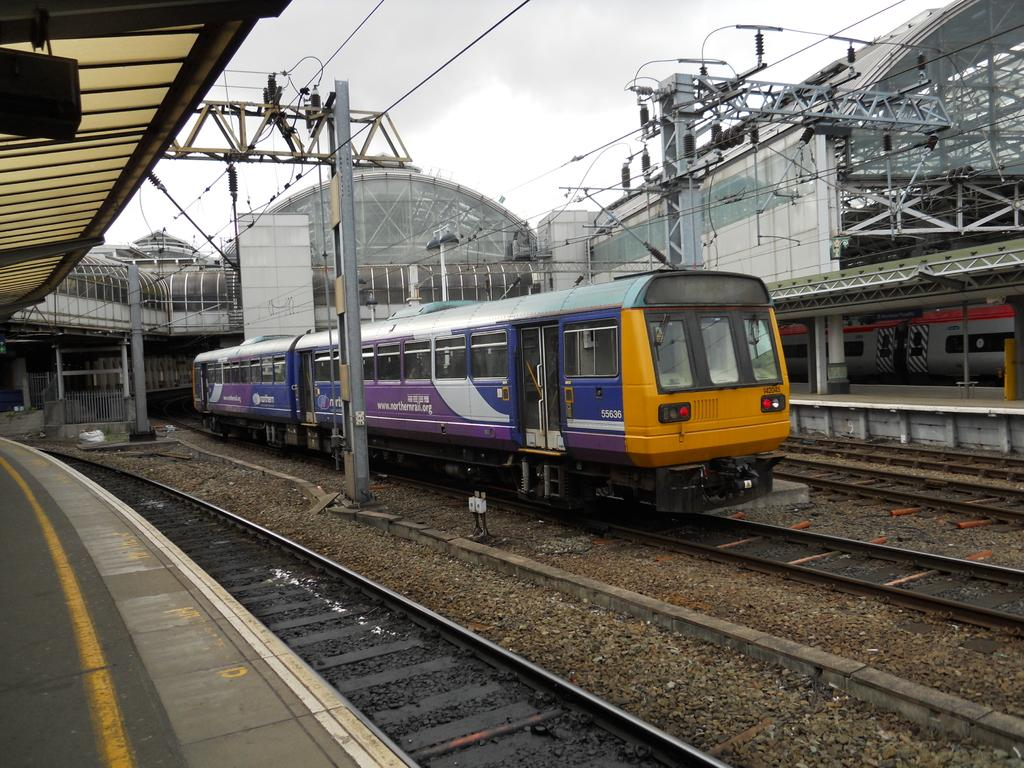What is the main subject of the image? The main subject of the image is a train. What is the train's position in the image? The train is on a track. What can be seen on both sides of the train? There are platforms on both sides of the train. What other objects are visible in the image? There are poles visible in the image. What can be seen in the background of the image? There is a board, a building, and the sky visible in the background of the image. What type of bead is being used to develop new ideas in the image? There is no bead or development of new ideas present in the image; it features a train on a track with platforms and background elements. 